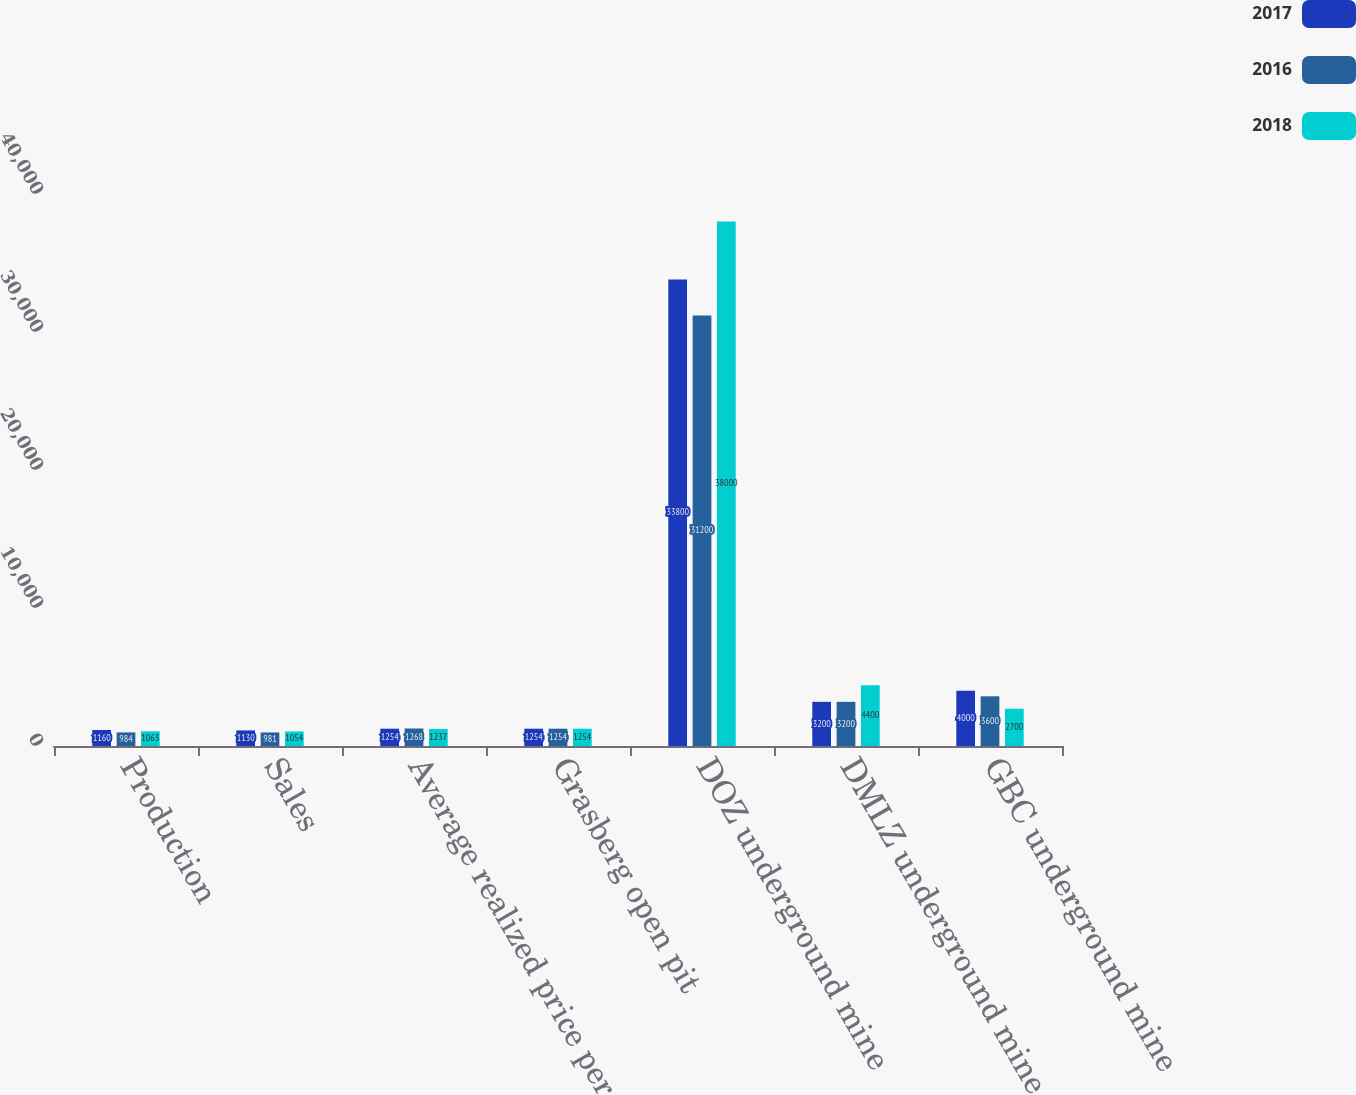<chart> <loc_0><loc_0><loc_500><loc_500><stacked_bar_chart><ecel><fcel>Production<fcel>Sales<fcel>Average realized price per<fcel>Grasberg open pit<fcel>DOZ underground mine<fcel>DMLZ underground mine<fcel>GBC underground mine<nl><fcel>2017<fcel>1160<fcel>1130<fcel>1254<fcel>1254<fcel>33800<fcel>3200<fcel>4000<nl><fcel>2016<fcel>984<fcel>981<fcel>1268<fcel>1254<fcel>31200<fcel>3200<fcel>3600<nl><fcel>2018<fcel>1063<fcel>1054<fcel>1237<fcel>1254<fcel>38000<fcel>4400<fcel>2700<nl></chart> 